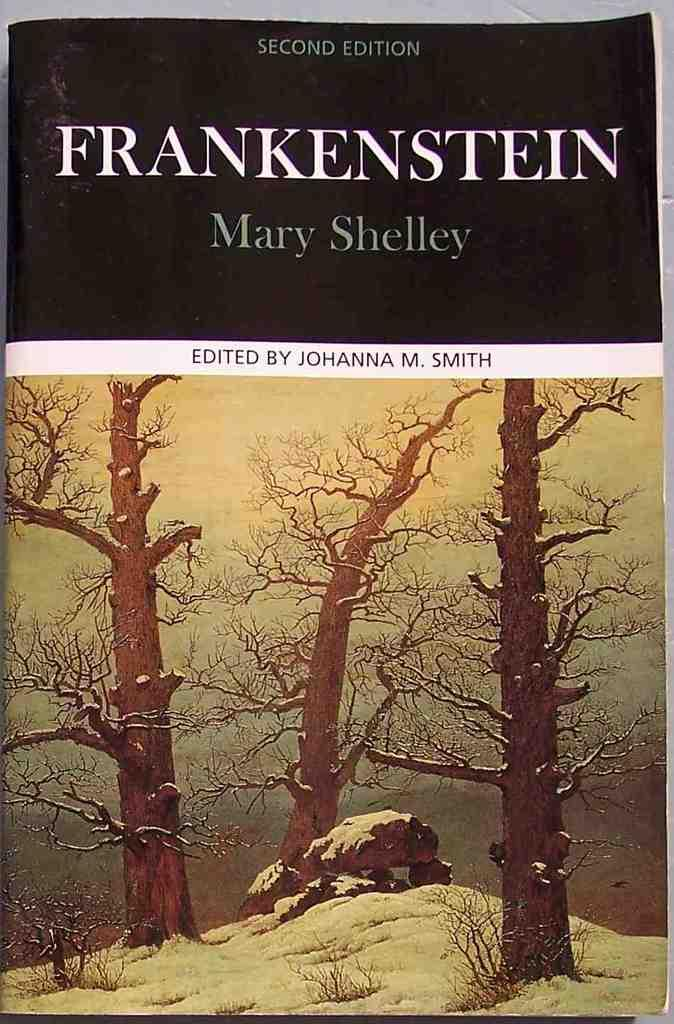<image>
Describe the image concisely. A second edition book of Frankenstein by Mary Shelley. 